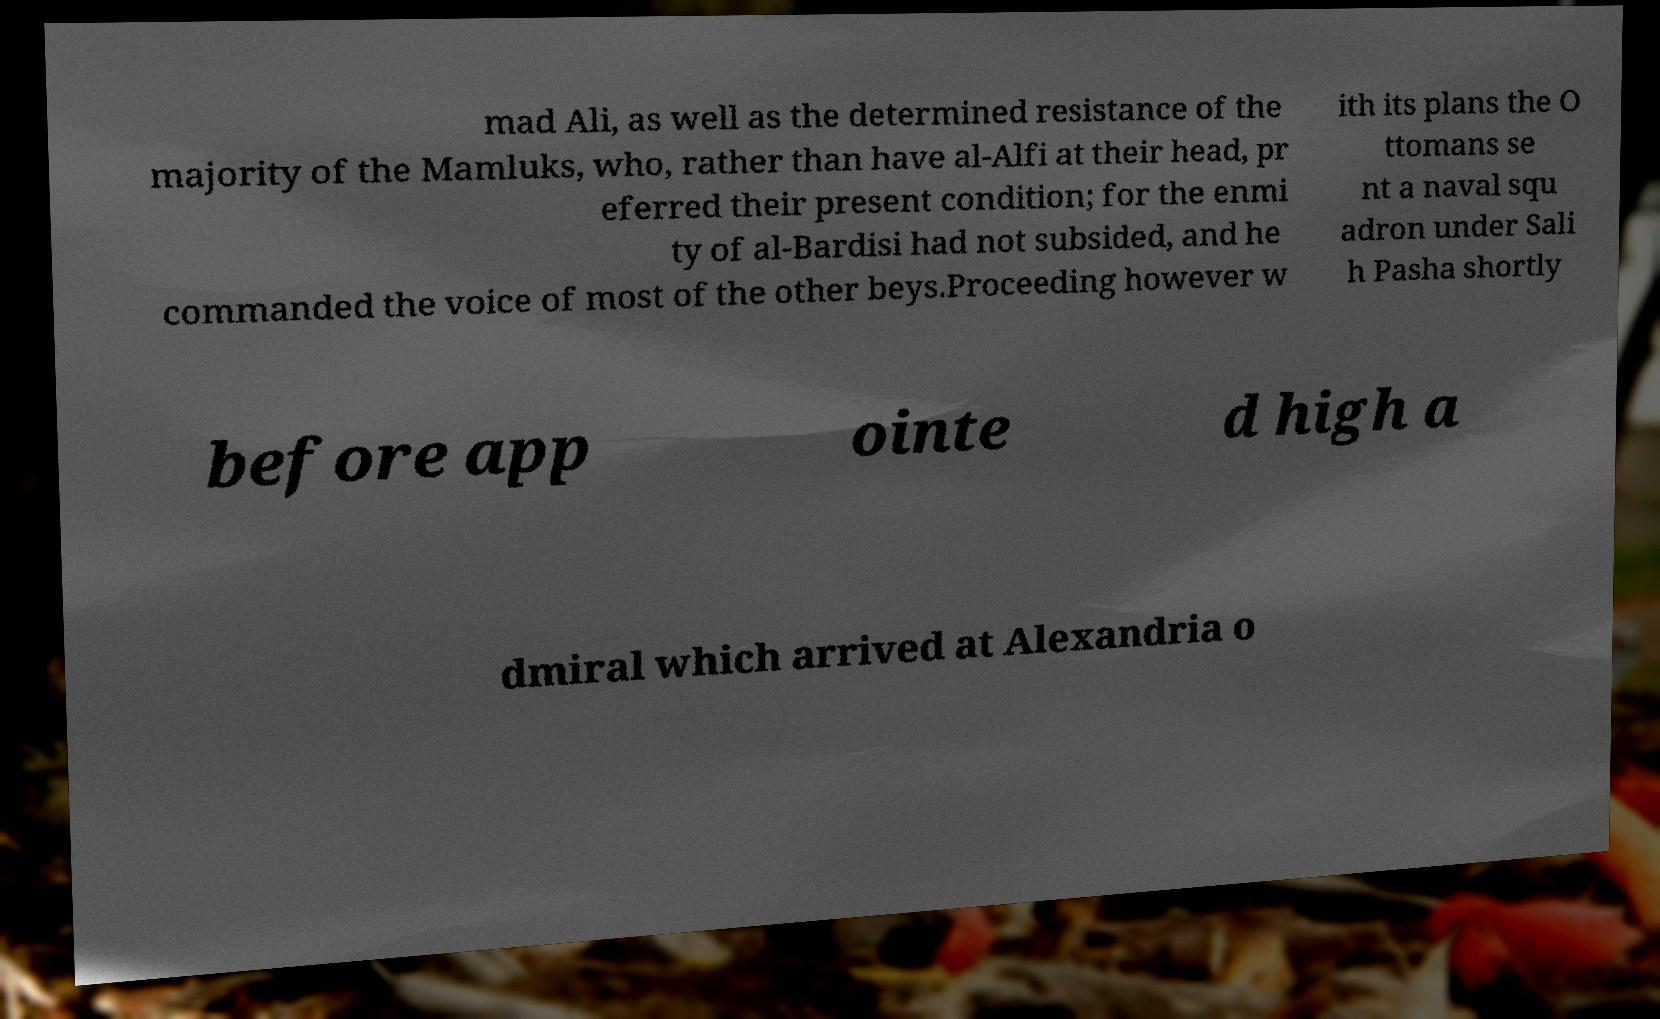Can you accurately transcribe the text from the provided image for me? mad Ali, as well as the determined resistance of the majority of the Mamluks, who, rather than have al-Alfi at their head, pr eferred their present condition; for the enmi ty of al-Bardisi had not subsided, and he commanded the voice of most of the other beys.Proceeding however w ith its plans the O ttomans se nt a naval squ adron under Sali h Pasha shortly before app ointe d high a dmiral which arrived at Alexandria o 